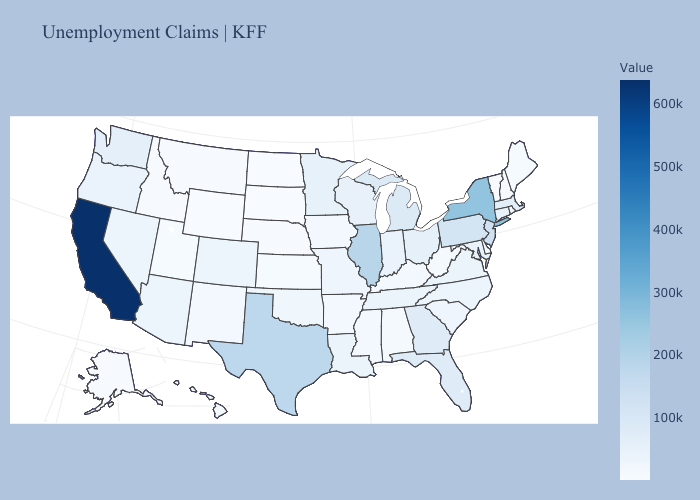Which states hav the highest value in the Northeast?
Give a very brief answer. New York. Does Illinois have the lowest value in the USA?
Short answer required. No. Among the states that border Missouri , which have the lowest value?
Keep it brief. Nebraska. Which states have the lowest value in the West?
Concise answer only. Wyoming. Which states have the lowest value in the USA?
Give a very brief answer. South Dakota. Which states hav the highest value in the Northeast?
Concise answer only. New York. Does Virginia have the lowest value in the USA?
Answer briefly. No. Does California have the highest value in the USA?
Write a very short answer. Yes. 